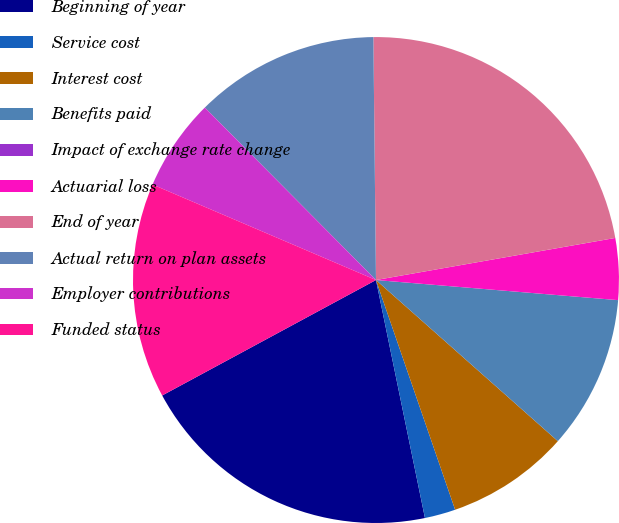Convert chart. <chart><loc_0><loc_0><loc_500><loc_500><pie_chart><fcel>Beginning of year<fcel>Service cost<fcel>Interest cost<fcel>Benefits paid<fcel>Impact of exchange rate change<fcel>Actuarial loss<fcel>End of year<fcel>Actual return on plan assets<fcel>Employer contributions<fcel>Funded status<nl><fcel>20.35%<fcel>2.05%<fcel>8.18%<fcel>10.22%<fcel>0.0%<fcel>4.09%<fcel>22.4%<fcel>12.27%<fcel>6.13%<fcel>14.31%<nl></chart> 